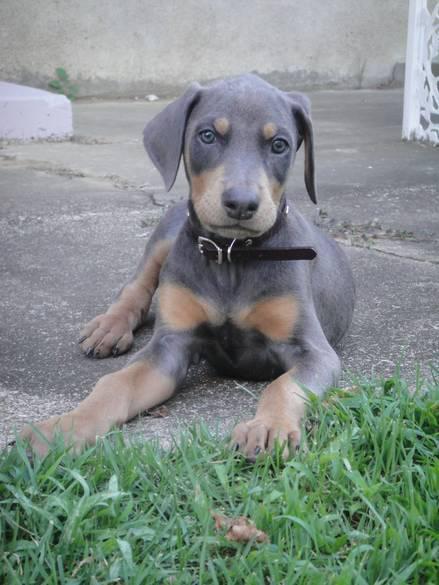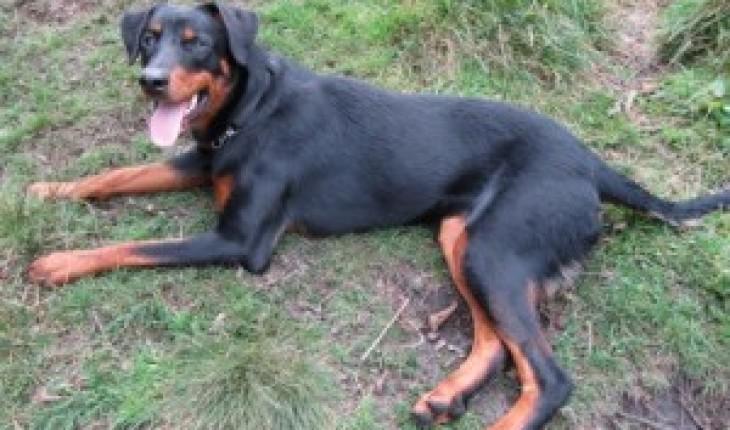The first image is the image on the left, the second image is the image on the right. Assess this claim about the two images: "The dogs in both images are lying down.". Correct or not? Answer yes or no. Yes. The first image is the image on the left, the second image is the image on the right. Considering the images on both sides, is "In the right image, there's a Doberman sitting down." valid? Answer yes or no. No. 